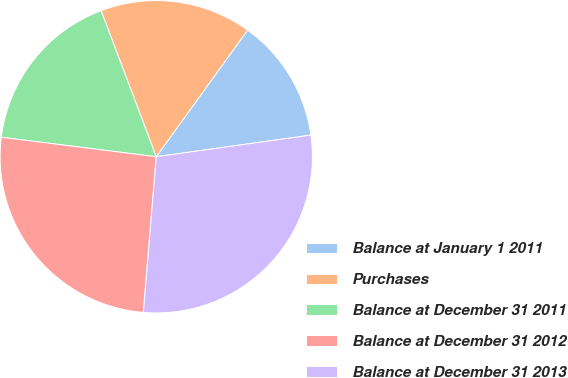Convert chart. <chart><loc_0><loc_0><loc_500><loc_500><pie_chart><fcel>Balance at January 1 2011<fcel>Purchases<fcel>Balance at December 31 2011<fcel>Balance at December 31 2012<fcel>Balance at December 31 2013<nl><fcel>12.84%<fcel>15.69%<fcel>17.26%<fcel>25.68%<fcel>28.53%<nl></chart> 